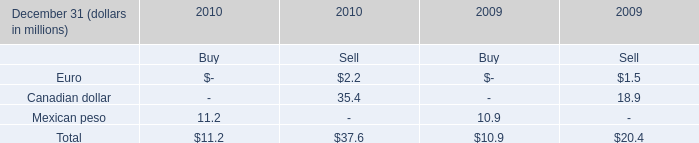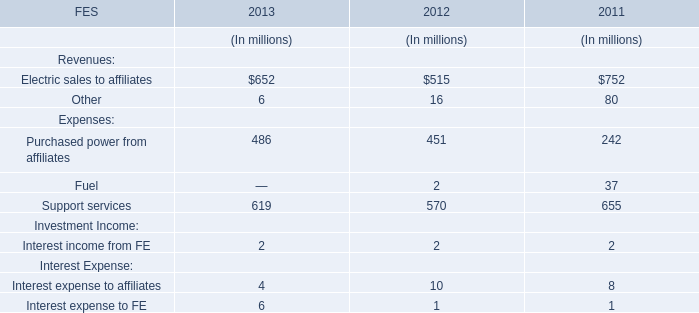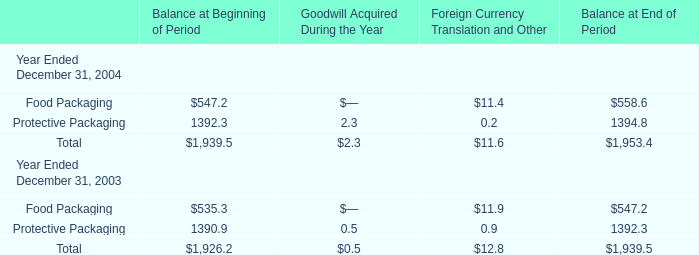What's the growth rate of Food Packaging for Balance at End of Period in 2004? 
Computations: ((558.6 - 547.2) / 547.2)
Answer: 0.02083. 